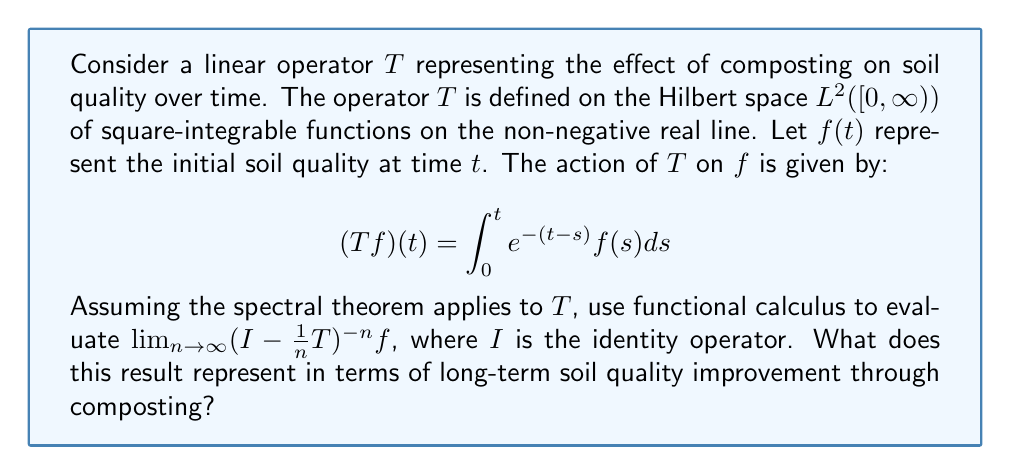Give your solution to this math problem. To solve this problem, we'll follow these steps:

1) First, we need to find the spectrum of $T$. The operator $T$ is a Volterra integral operator, and its spectrum consists of only the point $\{0\}$.

2) The resolvent of $T$ is given by:

   $R(\lambda, T) = (\lambda I - T)^{-1} = \lambda^{-1}I + \lambda^{-2}T + \lambda^{-3}T^2 + ...$

3) The expression $\lim_{n \to \infty} (I - \frac{1}{n}T)^{-n}$ is of the form $\lim_{n \to \infty} (I - \frac{1}{n}A)^{-n}$, which is the definition of the exponential of an operator: $e^A$.

4) Therefore, we need to calculate $e^T$.

5) Using the functional calculus, we can express $e^T$ as:

   $e^T = \int_{\sigma(T)} e^{\lambda} dE_{\lambda}$

   where $E_{\lambda}$ is the spectral measure associated with $T$.

6) Since the spectrum of $T$ is just $\{0\}$, this integral reduces to:

   $e^T = e^0 I = I$

7) Therefore, $\lim_{n \to \infty} (I - \frac{1}{n}T)^{-n} f = f$

In terms of soil quality improvement through composting, this result suggests that the long-term effect of composting (represented by repeated applications of $T$) approaches a steady state. The initial soil quality function $f(t)$ is preserved in the long run, indicating that composting maintains a stable soil quality over time rather than indefinitely improving it.
Answer: $\lim_{n \to \infty} (I - \frac{1}{n}T)^{-n} f = f$

This result indicates that the long-term impact of composting on soil quality reaches a steady state, maintaining the initial soil quality profile rather than continuously improving it. 